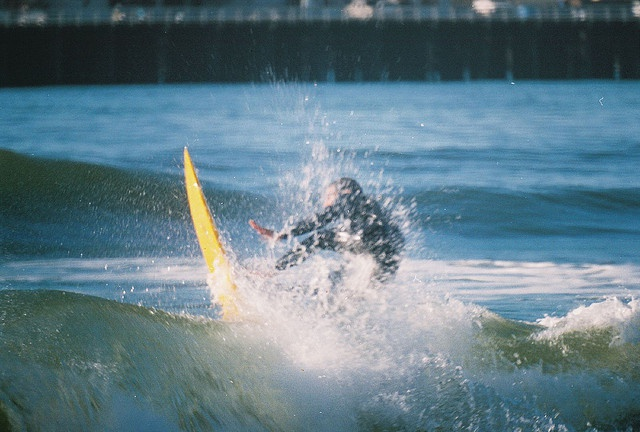Describe the objects in this image and their specific colors. I can see people in black, darkgray, gray, lightgray, and blue tones and surfboard in black, khaki, ivory, and tan tones in this image. 